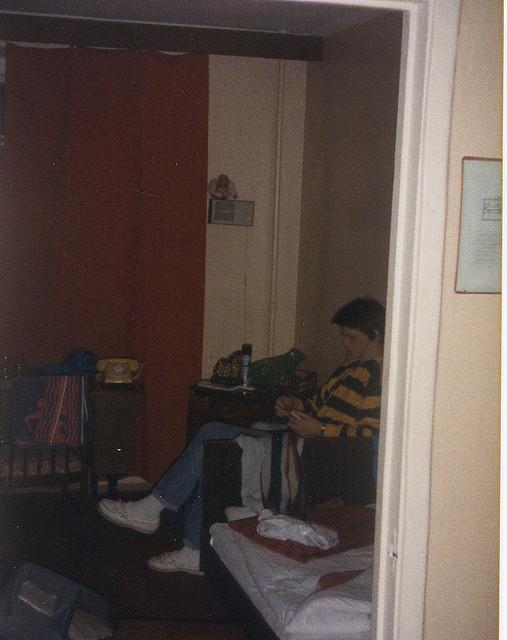What console is this person using?
Keep it brief. Wii. What room is this labeled as?
Keep it brief. Bedroom. Is the room dark?
Short answer required. Yes. Is there anything on the wall?
Concise answer only. Yes. What room is this?
Short answer required. Bedroom. Is this someone's bedroom?
Be succinct. No. Who owns the cats?
Keep it brief. Man. Is the floor carpeted?
Keep it brief. Yes. Which room is pictured in the image?
Answer briefly. Living room. Why is the room dark?
Write a very short answer. Night. What is shown?
Answer briefly. Boy. Is the room sunlit?
Quick response, please. No. Are any people visible in this image?
Quick response, please. Yes. What is this person using?
Write a very short answer. Phone. What color is the shoe?
Answer briefly. White. Where is the man?
Answer briefly. Living room. Is this an action scene?
Quick response, please. No. Who is in the room?
Write a very short answer. Man. Where is the furniture?
Quick response, please. Living room. Is the curtain closed?
Keep it brief. Yes. What is the accent color in the room?
Give a very brief answer. Red. 